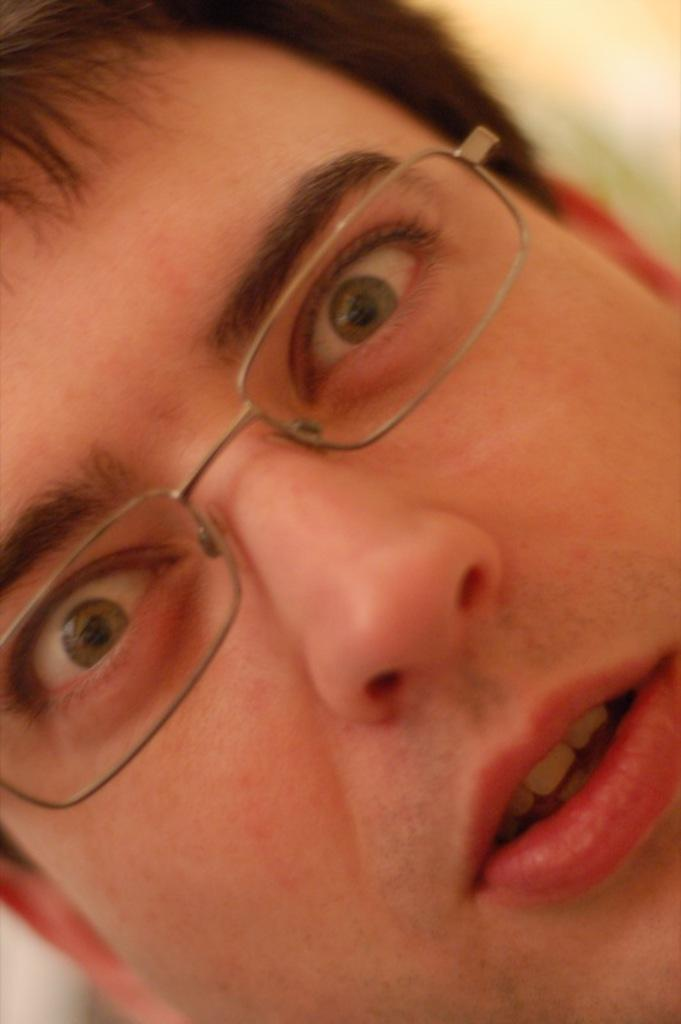What is the main subject of the picture? There is a person in the picture. Can you describe the person's appearance? The person is wearing spectacles. What can be observed about the background of the image? The background of the image is blurred. How many jellyfish can be seen in the middle of the image? There are no jellyfish present in the image. What type of thing is floating in the middle of the image? There is no thing floating in the middle of the image; the image only features a person with blurred background. 